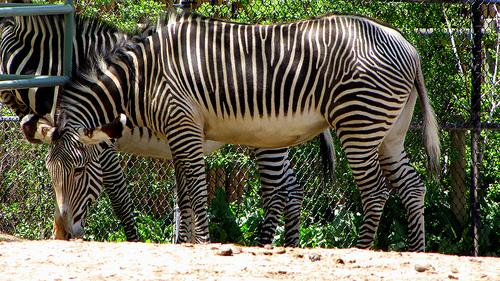What type of fence can be observed in the background of the image? A chain link fence is in the background of the image. How many zebras can you spot in the picture and describe their positions? There are two zebras: one is grazing in front of a fence, and the second zebra is standing in the background. Identify the primary animal present in the image and its action. A zebra grazing in front of a fence is the main animal and it's nibbling at the ground. Give a brief overview of the environment in which the main animal is performing its activity. The main zebra is grazing on the ground with dirt and clay, in front of a wire fence and near a green railing, with a second zebra in the background. Enumerate two other elements or objects that can be observed in the background of the photograph. In the background, there are wood posts and green leaves. Can you enumerate three distinct attributes of the main animal featured in the image? The zebra has black and white stripes, a white belly, and black eyes. What type of ground is the main zebra standing on in the picture? The zebra is standing on dirt and clay ground. Describe any other significant object or aspect in the photograph, apart from the main animal. There is a green metal railing with wood posts and green leaves in the background. What sentiment or mood would you associate with the scene captured in the image? The sentiment associated with the scene is calm and peaceful as the zebra grazes in its natural setting. Can you point out one body part of the main zebra that is specifically highlighted in the image information? The zebra's left ear is specifically highlighted in the image information. Do you think the zebras are aware of the water buffaloes grazing nearby? This instruction is misleading because water buffaloes are not mentioned or present in the image at all. The interrogative sentence makes the user question the presence of another object, despite it not actually being in the image. Have you seen the giraffe peeking out from behind the zebras? This instruction is misleading because giraffes are not mentioned or present in the image at all. Using an interrogative sentence to ask about a nonexistent object will confuse the user. Did you notice how the birds in the tree above are observing the zebras? This instruction is misleading because there is no mention or indication of birds or a tree in the image. The interrogative sentence questions the existence of an object that is not in the image, causing confusion for the user. Please point out the hippopotamus lurking in the water behind the fence. This instruction is misleading because there is no mention or evidence of a hippopotamus in the image. The declarative sentence instructs the user to find a nonexistent object, leading to confusion and frustration. It's fascinating how the elephant blends into the background, don't you agree? This instruction is misleading because it implies the presence of an elephant in the image, which is not the case. The declarative sentence indirectly asks the user about a nonexistent object, creating confusion. Notice how the lion is stealthily stalking its prey in the distance. This instruction is misleading because it implies the presence of a lion in the image, which is not the case. The declarative sentence introduces a nonexistent object and may mislead the user into searching for something that isn't there. 